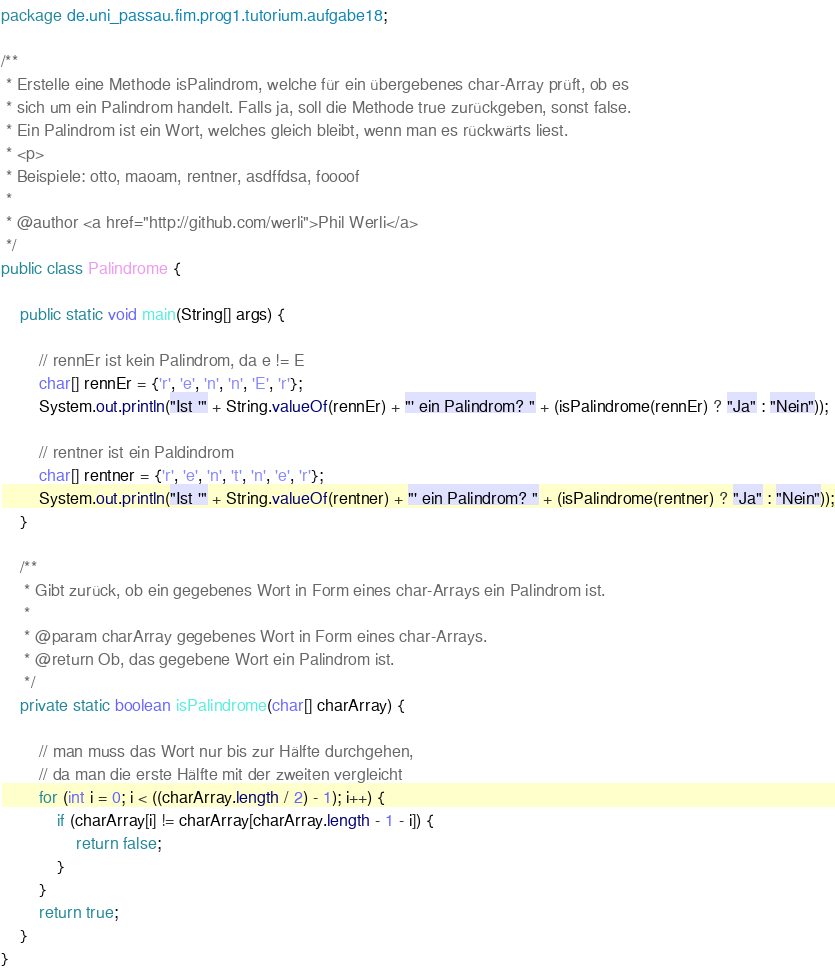Convert code to text. <code><loc_0><loc_0><loc_500><loc_500><_Java_>package de.uni_passau.fim.prog1.tutorium.aufgabe18;

/**
 * Erstelle eine Methode isPalindrom, welche für ein übergebenes char-Array prüft, ob es
 * sich um ein Palindrom handelt. Falls ja, soll die Methode true zurückgeben, sonst false.
 * Ein Palindrom ist ein Wort, welches gleich bleibt, wenn man es rückwärts liest.
 * <p>
 * Beispiele: otto, maoam, rentner, asdffdsa, foooof
 *
 * @author <a href="http://github.com/werli">Phil Werli</a>
 */
public class Palindrome {

    public static void main(String[] args) {

        // rennEr ist kein Palindrom, da e != E
        char[] rennEr = {'r', 'e', 'n', 'n', 'E', 'r'};
        System.out.println("Ist '" + String.valueOf(rennEr) + "' ein Palindrom? " + (isPalindrome(rennEr) ? "Ja" : "Nein"));

        // rentner ist ein Paldindrom
        char[] rentner = {'r', 'e', 'n', 't', 'n', 'e', 'r'};
        System.out.println("Ist '" + String.valueOf(rentner) + "' ein Palindrom? " + (isPalindrome(rentner) ? "Ja" : "Nein"));
    }

    /**
     * Gibt zurück, ob ein gegebenes Wort in Form eines char-Arrays ein Palindrom ist.
     *
     * @param charArray gegebenes Wort in Form eines char-Arrays.
     * @return Ob, das gegebene Wort ein Palindrom ist.
     */
    private static boolean isPalindrome(char[] charArray) {

        // man muss das Wort nur bis zur Hälfte durchgehen,
        // da man die erste Hälfte mit der zweiten vergleicht
        for (int i = 0; i < ((charArray.length / 2) - 1); i++) {
            if (charArray[i] != charArray[charArray.length - 1 - i]) {
                return false;
            }
        }
        return true;
    }
}
</code> 